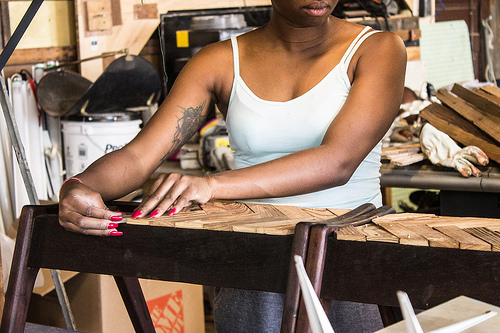<image>
Is there a woman next to the box? No. The woman is not positioned next to the box. They are located in different areas of the scene. 